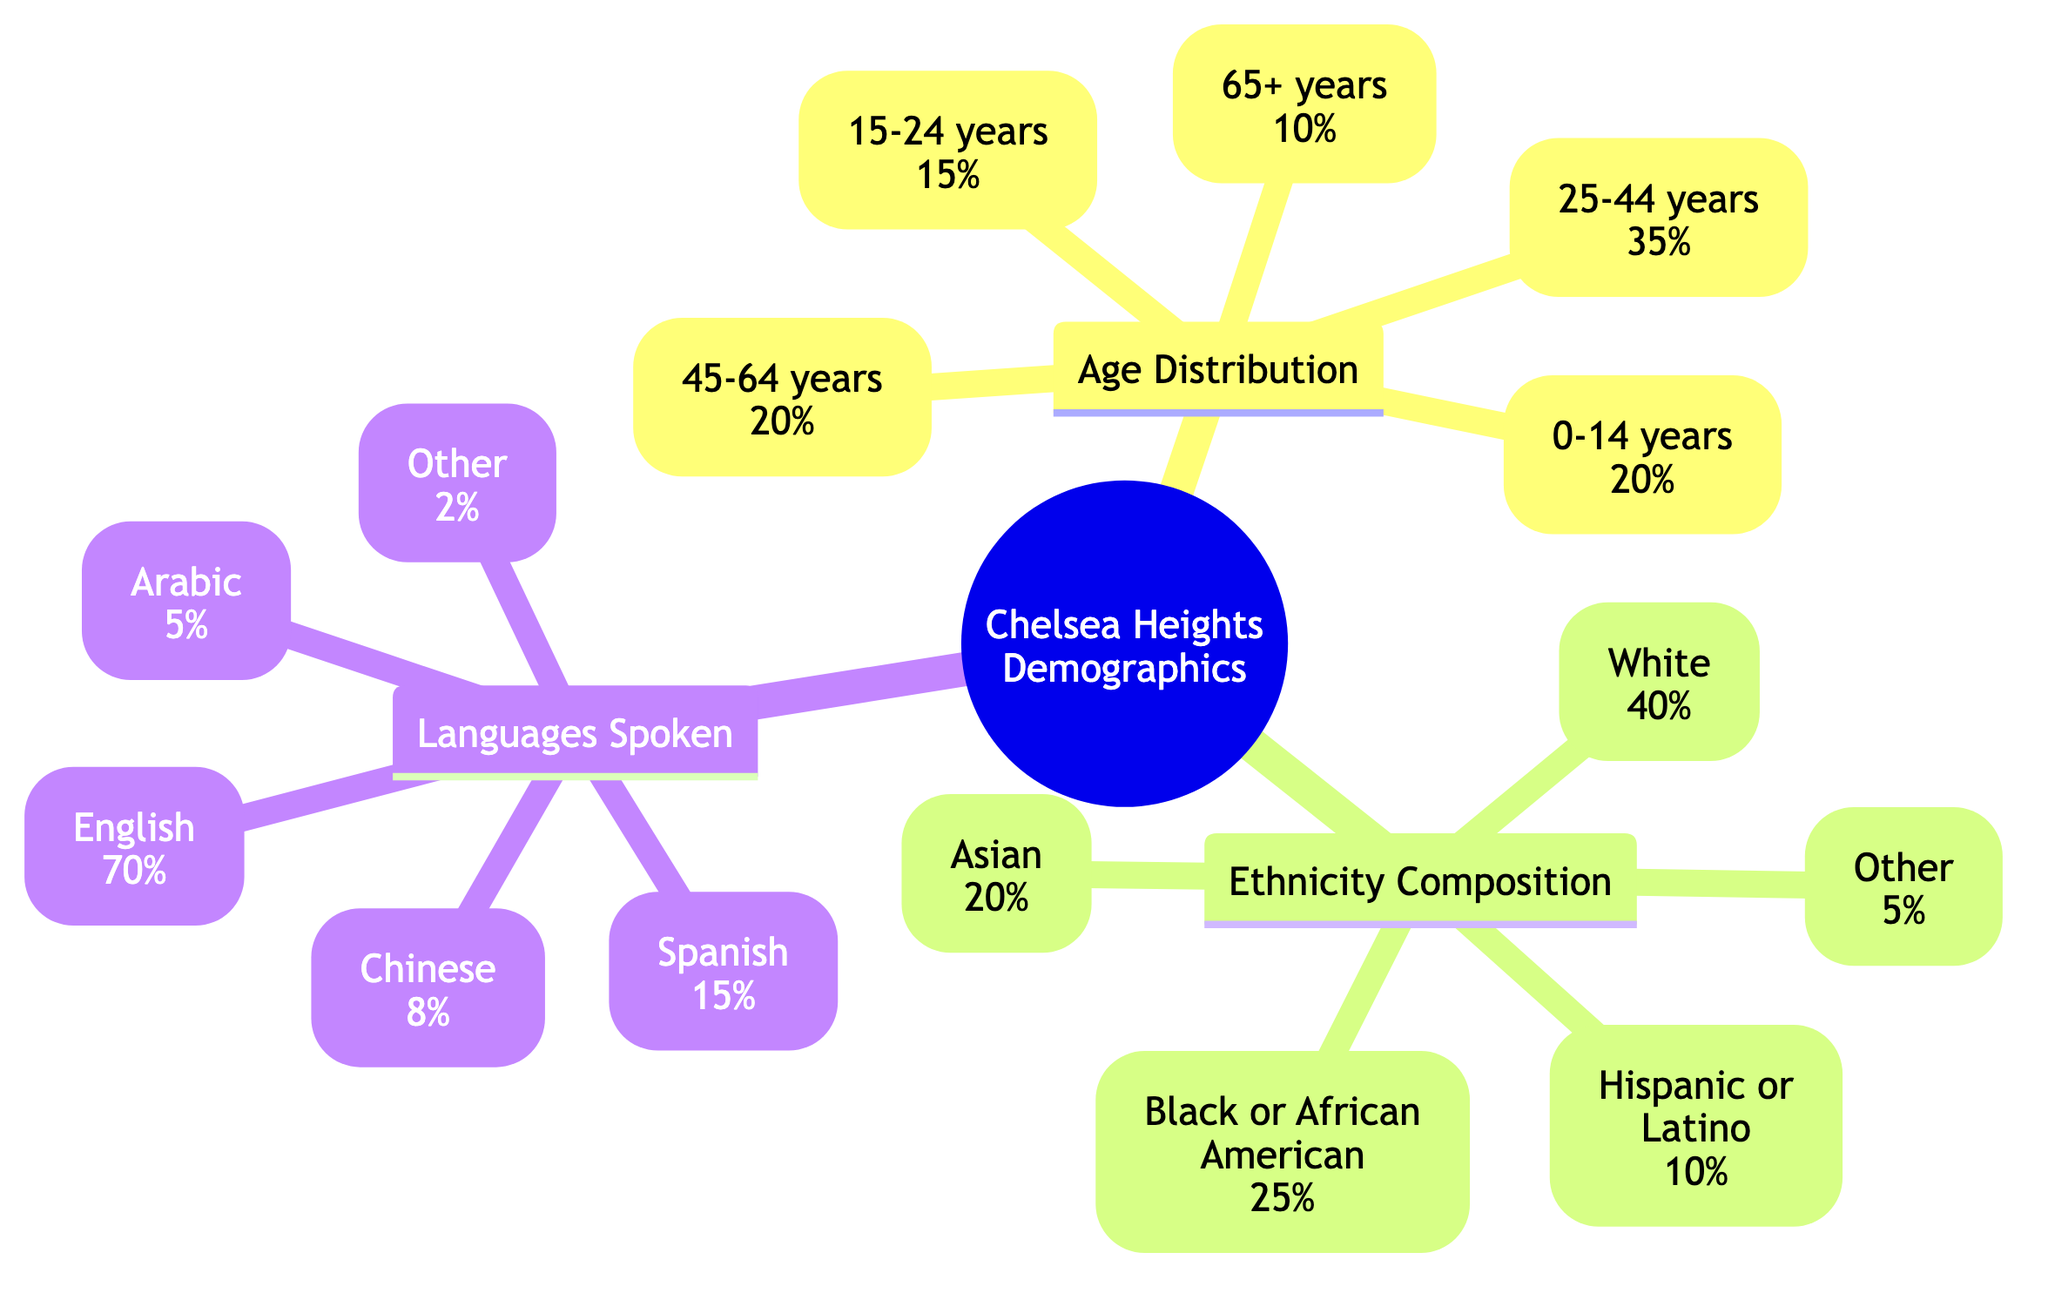What percentage of Chelsea Heights residents are aged 65 and older? The diagram shows that the segment representing the age group "65+ years" comprises 10% of the total population. This value is displayed directly under the Age Distribution section.
Answer: 10% Which age group has the highest representation in Chelsea Heights? The Age Distribution section lists several age groups and their corresponding percentages. "25-44 years" has the highest percentage at 35%, making it the most represented group.
Answer: 25-44 years What is the percentage of residents who identify as Hispanic or Latino? The Ethnicity Composition section specifically states that "Hispanic or Latino" residents make up 10% of the community's population, as shown in the diagram.
Answer: 10% How many ethnic categories are represented in the diagram? The Ethnicity Composition section lists five distinct categories (White, Black or African American, Asian, Hispanic or Latino, Other). Therefore, the total count is five.
Answer: 5 What percentage of Chelsea Heights speaks a language other than English? According to the Languages Spoken section, the percentages for languages other than English add up to 30% (15% Spanish, 8% Chinese, 5% Arabic, and 2% Other) since the total is 100%.
Answer: 30% Which ethnic group has a larger representation: Asian or Black or African American? The Ethnicity Composition section provides percentage values for both groups: "Black or African American" represents 25%, whereas "Asian" represents 20%. Since 25% is greater than 20%, Black or African American has a larger representation.
Answer: Black or African American What is the percentage of Chelsea Heights residents who speak Spanish? The Languages Spoken section of the diagram indicates that 15% of the residents speak Spanish, a figure stated directly in the visual.
Answer: 15% Is the percentage of residents aged 15-24 greater than those aged 0-14? By checking the Age Distribution section, "15-24 years" is represented by 15%, while "0-14 years" is represented by 20%. Since 20% is greater than 15%, the answer is that the percentage for 0-14 years is greater.
Answer: No What is the total percentage of the population that speaks either Chinese or Arabic? The Languages Spoken section lists "Chinese" at 8% and "Arabic" at 5%. Adding these two percentages together gives a total of 13%. This calculation indicates the portion of the population that speaks either language.
Answer: 13% 